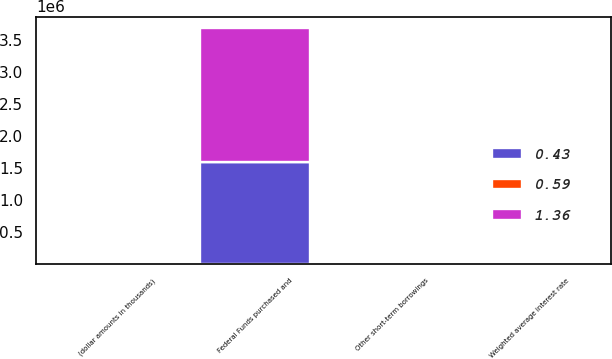<chart> <loc_0><loc_0><loc_500><loc_500><stacked_bar_chart><ecel><fcel>(dollar amounts in thousands)<fcel>Weighted average interest rate<fcel>Other short-term borrowings<fcel>Federal Funds purchased and<nl><fcel>0.43<fcel>2012<fcel>0.15<fcel>1.98<fcel>1.59008e+06<nl><fcel>0.59<fcel>2011<fcel>0.17<fcel>2.74<fcel>2.74<nl><fcel>1.36<fcel>2010<fcel>0.19<fcel>0.53<fcel>2.08443e+06<nl></chart> 